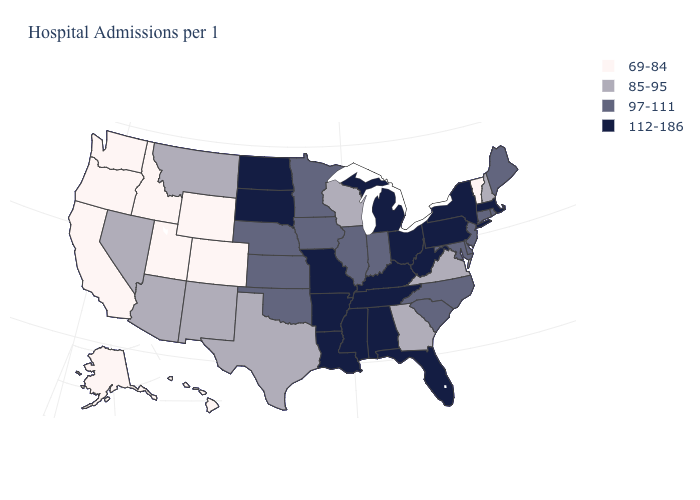What is the lowest value in the USA?
Quick response, please. 69-84. What is the value of Nebraska?
Keep it brief. 97-111. Is the legend a continuous bar?
Short answer required. No. Does Hawaii have the lowest value in the USA?
Be succinct. Yes. Among the states that border Connecticut , which have the highest value?
Write a very short answer. Massachusetts, New York. Name the states that have a value in the range 97-111?
Concise answer only. Connecticut, Delaware, Illinois, Indiana, Iowa, Kansas, Maine, Maryland, Minnesota, Nebraska, New Jersey, North Carolina, Oklahoma, Rhode Island, South Carolina. Does Mississippi have a lower value than California?
Keep it brief. No. Which states have the lowest value in the Northeast?
Give a very brief answer. Vermont. Which states have the highest value in the USA?
Keep it brief. Alabama, Arkansas, Florida, Kentucky, Louisiana, Massachusetts, Michigan, Mississippi, Missouri, New York, North Dakota, Ohio, Pennsylvania, South Dakota, Tennessee, West Virginia. Which states have the highest value in the USA?
Answer briefly. Alabama, Arkansas, Florida, Kentucky, Louisiana, Massachusetts, Michigan, Mississippi, Missouri, New York, North Dakota, Ohio, Pennsylvania, South Dakota, Tennessee, West Virginia. What is the highest value in the South ?
Be succinct. 112-186. Does Hawaii have the same value as Oregon?
Keep it brief. Yes. Does West Virginia have a higher value than Massachusetts?
Be succinct. No. What is the value of South Carolina?
Short answer required. 97-111. What is the highest value in states that border Mississippi?
Write a very short answer. 112-186. 